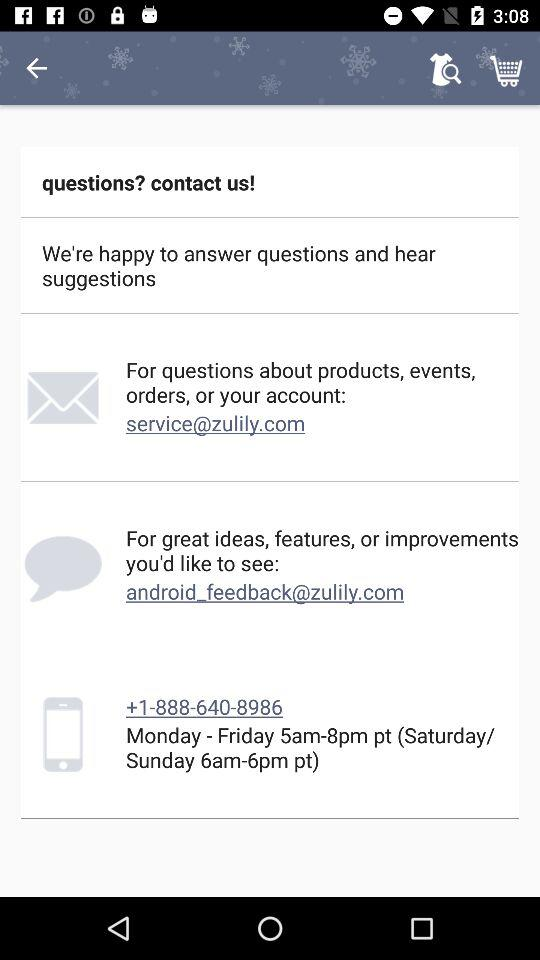What are the email address? The email address are "service@zulily.com", and "android_feedback@zulily.com". 